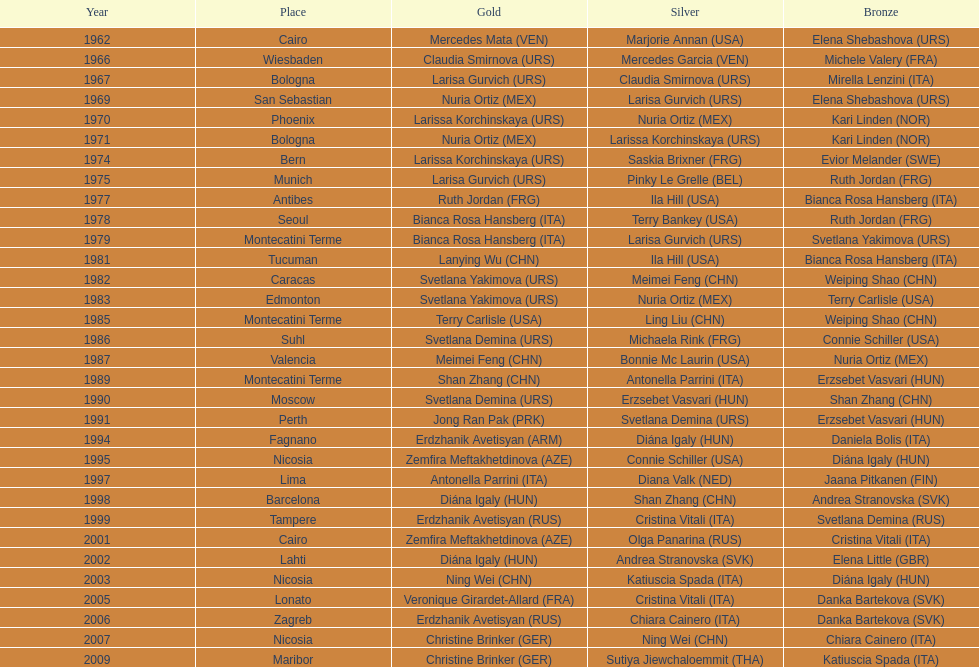In which nation can the highest number of bronze medals be found? Italy. 